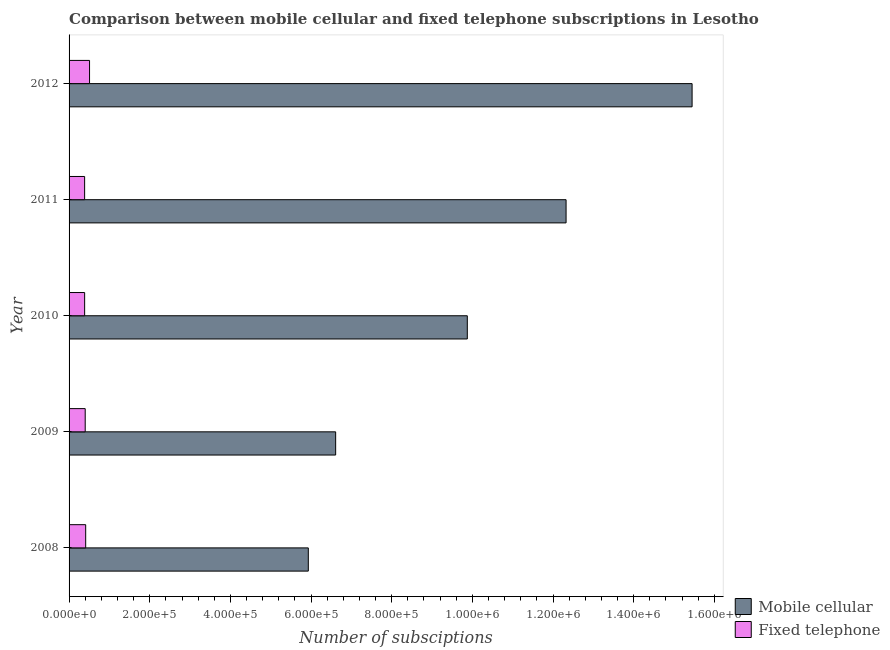How many groups of bars are there?
Make the answer very short. 5. Are the number of bars on each tick of the Y-axis equal?
Your response must be concise. Yes. What is the label of the 5th group of bars from the top?
Ensure brevity in your answer.  2008. In how many cases, is the number of bars for a given year not equal to the number of legend labels?
Provide a short and direct response. 0. What is the number of mobile cellular subscriptions in 2011?
Your answer should be very brief. 1.23e+06. Across all years, what is the maximum number of fixed telephone subscriptions?
Your answer should be very brief. 5.08e+04. Across all years, what is the minimum number of fixed telephone subscriptions?
Provide a short and direct response. 3.86e+04. In which year was the number of fixed telephone subscriptions minimum?
Provide a short and direct response. 2011. What is the total number of fixed telephone subscriptions in the graph?
Your answer should be very brief. 2.09e+05. What is the difference between the number of fixed telephone subscriptions in 2009 and that in 2011?
Make the answer very short. 1421. What is the difference between the number of fixed telephone subscriptions in 2008 and the number of mobile cellular subscriptions in 2010?
Your answer should be compact. -9.46e+05. What is the average number of fixed telephone subscriptions per year?
Your answer should be compact. 4.18e+04. In the year 2008, what is the difference between the number of mobile cellular subscriptions and number of fixed telephone subscriptions?
Offer a very short reply. 5.52e+05. What is the ratio of the number of mobile cellular subscriptions in 2010 to that in 2011?
Ensure brevity in your answer.  0.8. Is the difference between the number of fixed telephone subscriptions in 2009 and 2012 greater than the difference between the number of mobile cellular subscriptions in 2009 and 2012?
Keep it short and to the point. Yes. What is the difference between the highest and the second highest number of fixed telephone subscriptions?
Give a very brief answer. 9579. What is the difference between the highest and the lowest number of mobile cellular subscriptions?
Offer a very short reply. 9.52e+05. What does the 2nd bar from the top in 2010 represents?
Your response must be concise. Mobile cellular. What does the 1st bar from the bottom in 2012 represents?
Offer a very short reply. Mobile cellular. How many years are there in the graph?
Your response must be concise. 5. What is the difference between two consecutive major ticks on the X-axis?
Offer a very short reply. 2.00e+05. Are the values on the major ticks of X-axis written in scientific E-notation?
Keep it short and to the point. Yes. Does the graph contain grids?
Ensure brevity in your answer.  No. What is the title of the graph?
Give a very brief answer. Comparison between mobile cellular and fixed telephone subscriptions in Lesotho. Does "Imports" appear as one of the legend labels in the graph?
Your answer should be very brief. No. What is the label or title of the X-axis?
Give a very brief answer. Number of subsciptions. What is the label or title of the Y-axis?
Your response must be concise. Year. What is the Number of subsciptions of Mobile cellular in 2008?
Provide a succinct answer. 5.93e+05. What is the Number of subsciptions of Fixed telephone in 2008?
Offer a terse response. 4.12e+04. What is the Number of subsciptions in Mobile cellular in 2009?
Offer a terse response. 6.61e+05. What is the Number of subsciptions in Fixed telephone in 2009?
Your answer should be very brief. 4.00e+04. What is the Number of subsciptions of Mobile cellular in 2010?
Your answer should be very brief. 9.87e+05. What is the Number of subsciptions of Fixed telephone in 2010?
Provide a succinct answer. 3.86e+04. What is the Number of subsciptions in Mobile cellular in 2011?
Provide a short and direct response. 1.23e+06. What is the Number of subsciptions in Fixed telephone in 2011?
Offer a terse response. 3.86e+04. What is the Number of subsciptions in Mobile cellular in 2012?
Provide a succinct answer. 1.54e+06. What is the Number of subsciptions of Fixed telephone in 2012?
Your answer should be very brief. 5.08e+04. Across all years, what is the maximum Number of subsciptions of Mobile cellular?
Your answer should be compact. 1.54e+06. Across all years, what is the maximum Number of subsciptions in Fixed telephone?
Offer a very short reply. 5.08e+04. Across all years, what is the minimum Number of subsciptions of Mobile cellular?
Provide a succinct answer. 5.93e+05. Across all years, what is the minimum Number of subsciptions of Fixed telephone?
Offer a terse response. 3.86e+04. What is the total Number of subsciptions in Mobile cellular in the graph?
Offer a terse response. 5.02e+06. What is the total Number of subsciptions in Fixed telephone in the graph?
Keep it short and to the point. 2.09e+05. What is the difference between the Number of subsciptions of Mobile cellular in 2008 and that in 2009?
Offer a very short reply. -6.78e+04. What is the difference between the Number of subsciptions in Fixed telephone in 2008 and that in 2009?
Provide a succinct answer. 1190. What is the difference between the Number of subsciptions in Mobile cellular in 2008 and that in 2010?
Your response must be concise. -3.94e+05. What is the difference between the Number of subsciptions in Fixed telephone in 2008 and that in 2010?
Keep it short and to the point. 2578. What is the difference between the Number of subsciptions of Mobile cellular in 2008 and that in 2011?
Offer a very short reply. -6.39e+05. What is the difference between the Number of subsciptions of Fixed telephone in 2008 and that in 2011?
Provide a short and direct response. 2611. What is the difference between the Number of subsciptions of Mobile cellular in 2008 and that in 2012?
Your response must be concise. -9.52e+05. What is the difference between the Number of subsciptions of Fixed telephone in 2008 and that in 2012?
Make the answer very short. -9579. What is the difference between the Number of subsciptions of Mobile cellular in 2009 and that in 2010?
Your answer should be compact. -3.26e+05. What is the difference between the Number of subsciptions of Fixed telephone in 2009 and that in 2010?
Ensure brevity in your answer.  1388. What is the difference between the Number of subsciptions of Mobile cellular in 2009 and that in 2011?
Your answer should be very brief. -5.71e+05. What is the difference between the Number of subsciptions in Fixed telephone in 2009 and that in 2011?
Offer a very short reply. 1421. What is the difference between the Number of subsciptions of Mobile cellular in 2009 and that in 2012?
Give a very brief answer. -8.84e+05. What is the difference between the Number of subsciptions of Fixed telephone in 2009 and that in 2012?
Your answer should be very brief. -1.08e+04. What is the difference between the Number of subsciptions of Mobile cellular in 2010 and that in 2011?
Provide a succinct answer. -2.45e+05. What is the difference between the Number of subsciptions of Fixed telephone in 2010 and that in 2011?
Offer a terse response. 33. What is the difference between the Number of subsciptions in Mobile cellular in 2010 and that in 2012?
Provide a succinct answer. -5.57e+05. What is the difference between the Number of subsciptions in Fixed telephone in 2010 and that in 2012?
Offer a very short reply. -1.22e+04. What is the difference between the Number of subsciptions of Mobile cellular in 2011 and that in 2012?
Your answer should be very brief. -3.12e+05. What is the difference between the Number of subsciptions in Fixed telephone in 2011 and that in 2012?
Give a very brief answer. -1.22e+04. What is the difference between the Number of subsciptions in Mobile cellular in 2008 and the Number of subsciptions in Fixed telephone in 2009?
Make the answer very short. 5.53e+05. What is the difference between the Number of subsciptions of Mobile cellular in 2008 and the Number of subsciptions of Fixed telephone in 2010?
Your response must be concise. 5.55e+05. What is the difference between the Number of subsciptions in Mobile cellular in 2008 and the Number of subsciptions in Fixed telephone in 2011?
Your answer should be compact. 5.55e+05. What is the difference between the Number of subsciptions in Mobile cellular in 2008 and the Number of subsciptions in Fixed telephone in 2012?
Make the answer very short. 5.42e+05. What is the difference between the Number of subsciptions in Mobile cellular in 2009 and the Number of subsciptions in Fixed telephone in 2010?
Provide a short and direct response. 6.22e+05. What is the difference between the Number of subsciptions in Mobile cellular in 2009 and the Number of subsciptions in Fixed telephone in 2011?
Your response must be concise. 6.22e+05. What is the difference between the Number of subsciptions in Mobile cellular in 2009 and the Number of subsciptions in Fixed telephone in 2012?
Your answer should be compact. 6.10e+05. What is the difference between the Number of subsciptions in Mobile cellular in 2010 and the Number of subsciptions in Fixed telephone in 2011?
Provide a succinct answer. 9.49e+05. What is the difference between the Number of subsciptions of Mobile cellular in 2010 and the Number of subsciptions of Fixed telephone in 2012?
Offer a very short reply. 9.37e+05. What is the difference between the Number of subsciptions in Mobile cellular in 2011 and the Number of subsciptions in Fixed telephone in 2012?
Your answer should be very brief. 1.18e+06. What is the average Number of subsciptions of Mobile cellular per year?
Your answer should be compact. 1.00e+06. What is the average Number of subsciptions in Fixed telephone per year?
Ensure brevity in your answer.  4.18e+04. In the year 2008, what is the difference between the Number of subsciptions in Mobile cellular and Number of subsciptions in Fixed telephone?
Make the answer very short. 5.52e+05. In the year 2009, what is the difference between the Number of subsciptions of Mobile cellular and Number of subsciptions of Fixed telephone?
Your answer should be compact. 6.21e+05. In the year 2010, what is the difference between the Number of subsciptions of Mobile cellular and Number of subsciptions of Fixed telephone?
Your response must be concise. 9.49e+05. In the year 2011, what is the difference between the Number of subsciptions in Mobile cellular and Number of subsciptions in Fixed telephone?
Ensure brevity in your answer.  1.19e+06. In the year 2012, what is the difference between the Number of subsciptions in Mobile cellular and Number of subsciptions in Fixed telephone?
Your response must be concise. 1.49e+06. What is the ratio of the Number of subsciptions in Mobile cellular in 2008 to that in 2009?
Keep it short and to the point. 0.9. What is the ratio of the Number of subsciptions in Fixed telephone in 2008 to that in 2009?
Your answer should be compact. 1.03. What is the ratio of the Number of subsciptions of Mobile cellular in 2008 to that in 2010?
Make the answer very short. 0.6. What is the ratio of the Number of subsciptions in Fixed telephone in 2008 to that in 2010?
Your response must be concise. 1.07. What is the ratio of the Number of subsciptions of Mobile cellular in 2008 to that in 2011?
Make the answer very short. 0.48. What is the ratio of the Number of subsciptions in Fixed telephone in 2008 to that in 2011?
Give a very brief answer. 1.07. What is the ratio of the Number of subsciptions of Mobile cellular in 2008 to that in 2012?
Your answer should be compact. 0.38. What is the ratio of the Number of subsciptions of Fixed telephone in 2008 to that in 2012?
Provide a succinct answer. 0.81. What is the ratio of the Number of subsciptions in Mobile cellular in 2009 to that in 2010?
Give a very brief answer. 0.67. What is the ratio of the Number of subsciptions of Fixed telephone in 2009 to that in 2010?
Your response must be concise. 1.04. What is the ratio of the Number of subsciptions in Mobile cellular in 2009 to that in 2011?
Your answer should be compact. 0.54. What is the ratio of the Number of subsciptions in Fixed telephone in 2009 to that in 2011?
Offer a very short reply. 1.04. What is the ratio of the Number of subsciptions in Mobile cellular in 2009 to that in 2012?
Ensure brevity in your answer.  0.43. What is the ratio of the Number of subsciptions of Fixed telephone in 2009 to that in 2012?
Your answer should be very brief. 0.79. What is the ratio of the Number of subsciptions of Mobile cellular in 2010 to that in 2011?
Offer a very short reply. 0.8. What is the ratio of the Number of subsciptions in Mobile cellular in 2010 to that in 2012?
Offer a very short reply. 0.64. What is the ratio of the Number of subsciptions of Fixed telephone in 2010 to that in 2012?
Your answer should be compact. 0.76. What is the ratio of the Number of subsciptions in Mobile cellular in 2011 to that in 2012?
Your answer should be compact. 0.8. What is the ratio of the Number of subsciptions in Fixed telephone in 2011 to that in 2012?
Ensure brevity in your answer.  0.76. What is the difference between the highest and the second highest Number of subsciptions of Mobile cellular?
Offer a terse response. 3.12e+05. What is the difference between the highest and the second highest Number of subsciptions in Fixed telephone?
Offer a terse response. 9579. What is the difference between the highest and the lowest Number of subsciptions in Mobile cellular?
Make the answer very short. 9.52e+05. What is the difference between the highest and the lowest Number of subsciptions in Fixed telephone?
Ensure brevity in your answer.  1.22e+04. 